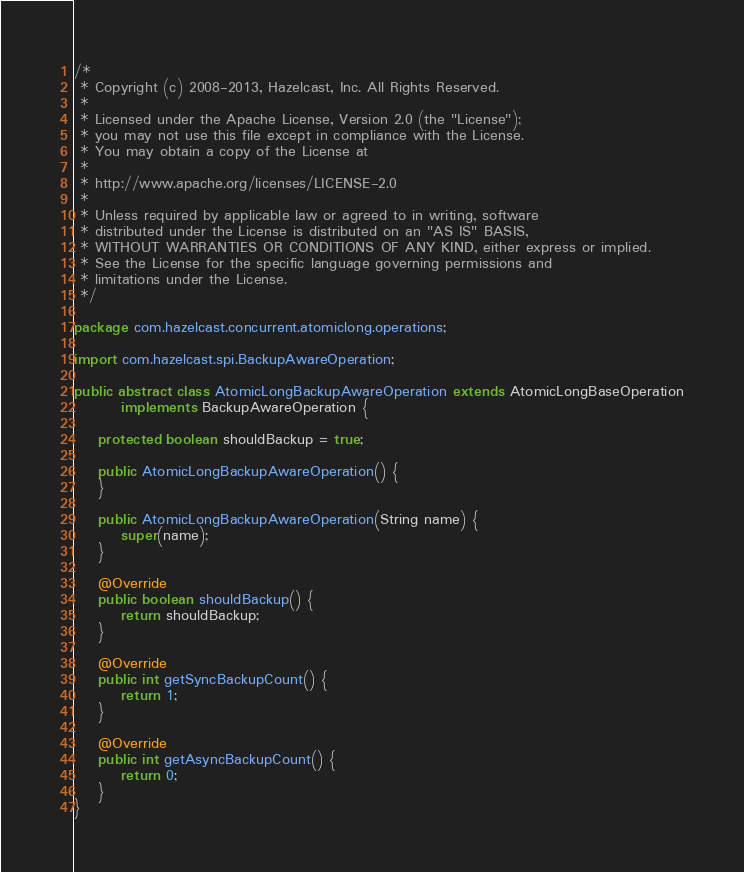Convert code to text. <code><loc_0><loc_0><loc_500><loc_500><_Java_>/*
 * Copyright (c) 2008-2013, Hazelcast, Inc. All Rights Reserved.
 *
 * Licensed under the Apache License, Version 2.0 (the "License");
 * you may not use this file except in compliance with the License.
 * You may obtain a copy of the License at
 *
 * http://www.apache.org/licenses/LICENSE-2.0
 *
 * Unless required by applicable law or agreed to in writing, software
 * distributed under the License is distributed on an "AS IS" BASIS,
 * WITHOUT WARRANTIES OR CONDITIONS OF ANY KIND, either express or implied.
 * See the License for the specific language governing permissions and
 * limitations under the License.
 */

package com.hazelcast.concurrent.atomiclong.operations;

import com.hazelcast.spi.BackupAwareOperation;

public abstract class AtomicLongBackupAwareOperation extends AtomicLongBaseOperation
        implements BackupAwareOperation {

    protected boolean shouldBackup = true;

    public AtomicLongBackupAwareOperation() {
    }

    public AtomicLongBackupAwareOperation(String name) {
        super(name);
    }

    @Override
    public boolean shouldBackup() {
        return shouldBackup;
    }

    @Override
    public int getSyncBackupCount() {
        return 1;
    }

    @Override
    public int getAsyncBackupCount() {
        return 0;
    }
}
</code> 